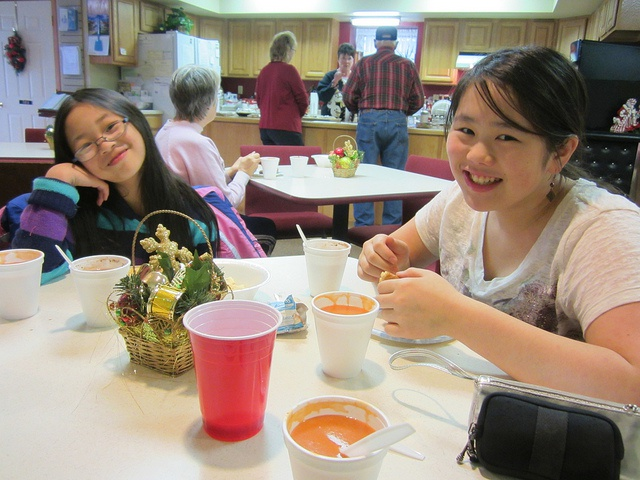Describe the objects in this image and their specific colors. I can see people in purple, gray, tan, and black tones, dining table in purple, lightgray, tan, and darkgray tones, people in purple, black, gray, and tan tones, potted plant in purple, olive, black, and tan tones, and cup in purple, red, lightpink, and brown tones in this image. 